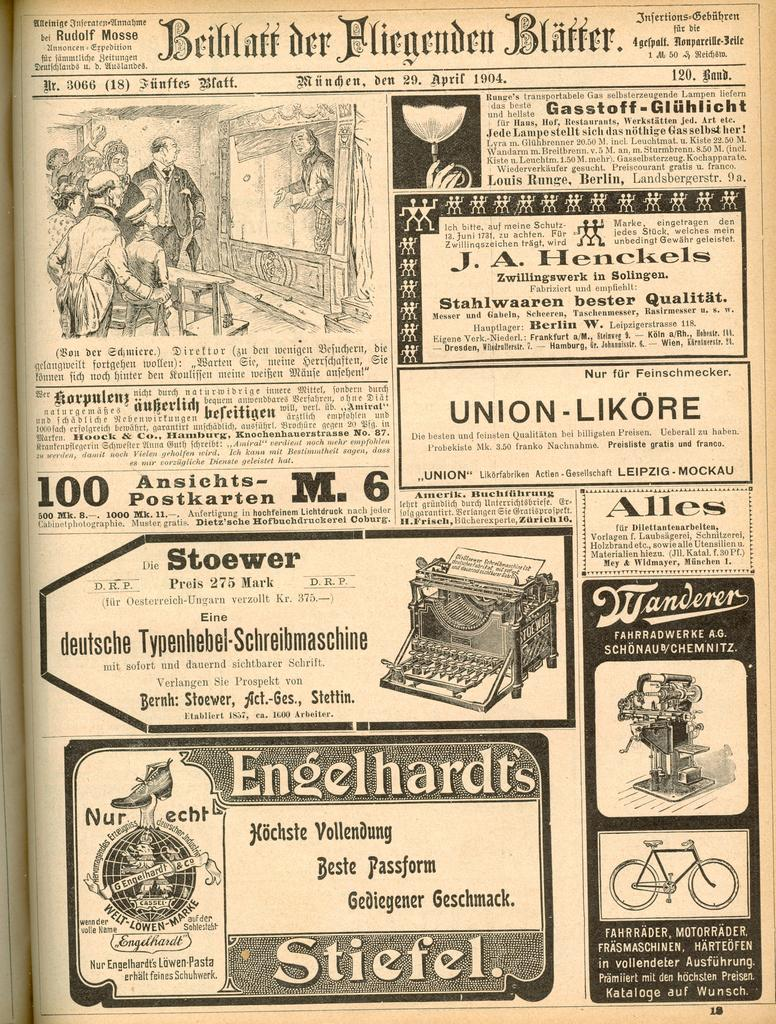<image>
Summarize the visual content of the image. Black and white poster which says "Engelhardt's Stiefel" on the bottom. 